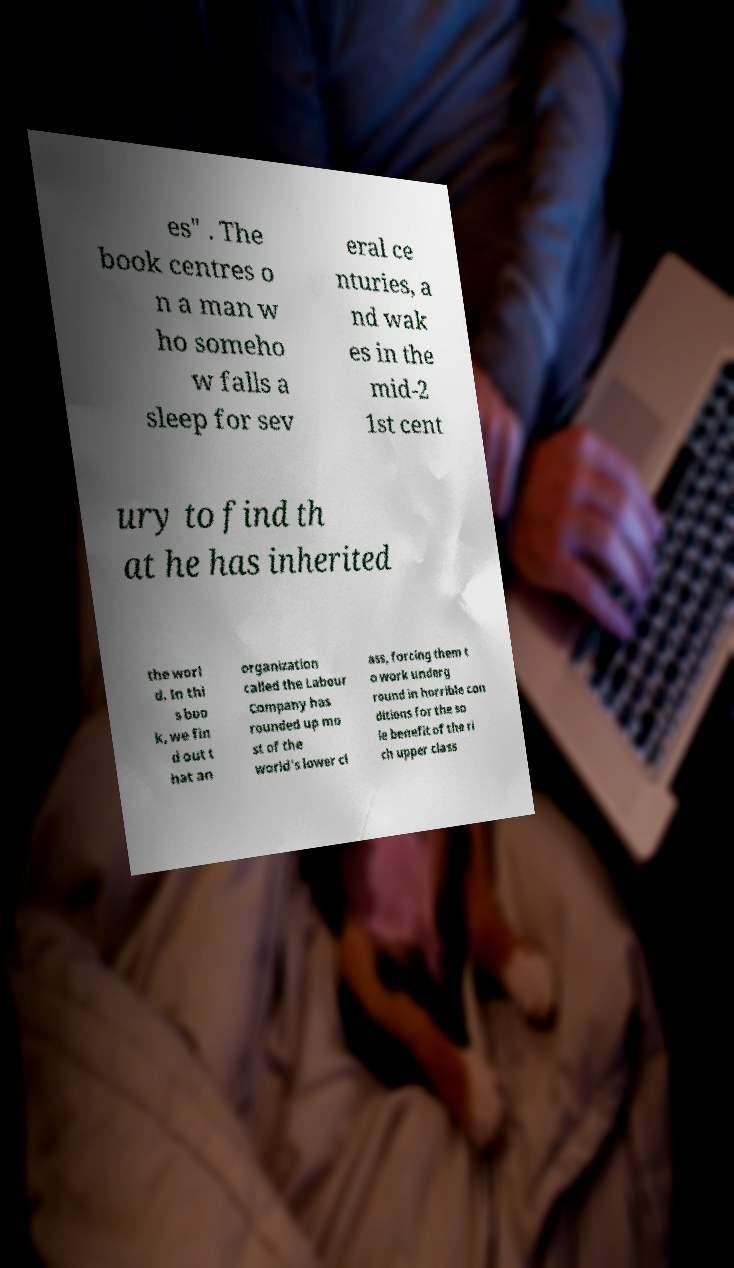For documentation purposes, I need the text within this image transcribed. Could you provide that? es" . The book centres o n a man w ho someho w falls a sleep for sev eral ce nturies, a nd wak es in the mid-2 1st cent ury to find th at he has inherited the worl d. In thi s boo k, we fin d out t hat an organization called the Labour Company has rounded up mo st of the world's lower cl ass, forcing them t o work underg round in horrible con ditions for the so le benefit of the ri ch upper class 